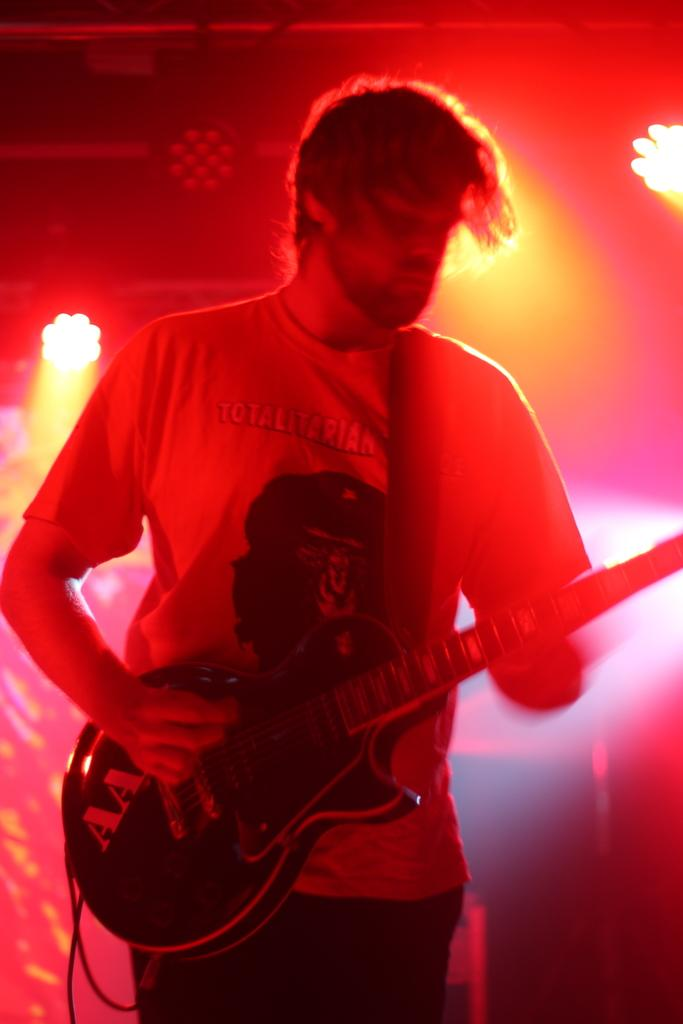What is the main subject of the image? There is a person in the image. What is the person holding in the image? The person is holding a guitar. What can be seen in the background of the image? There are lights and objects in the background of the image. What type of property can be seen in the image? There is no property visible in the image; it features a person holding a guitar with lights and objects in the background. Can you tell me how many matches are present in the image? There are no matches present in the image. 